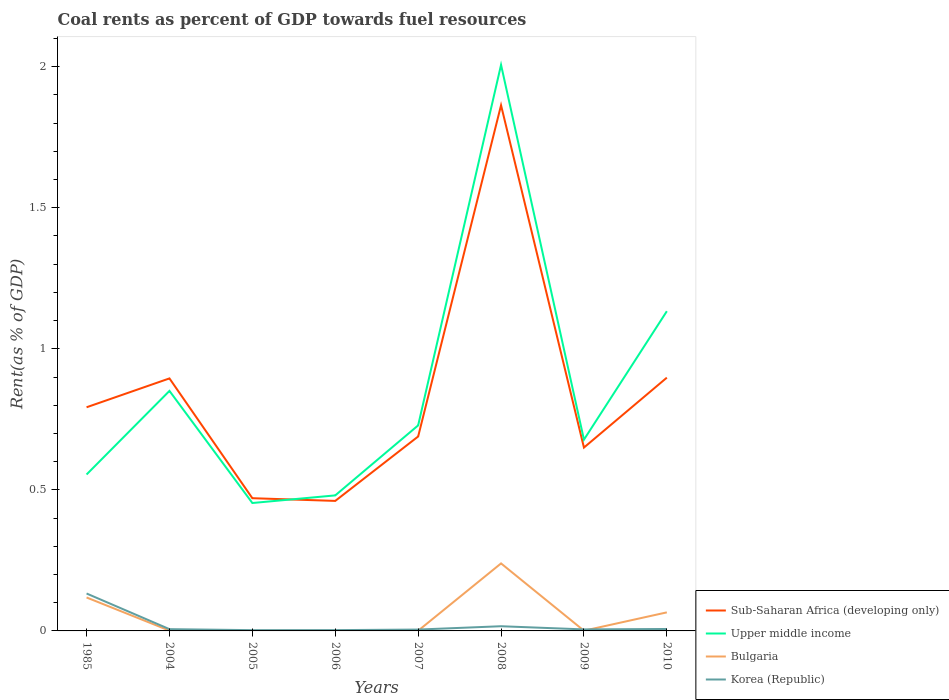Is the number of lines equal to the number of legend labels?
Offer a terse response. Yes. Across all years, what is the maximum coal rent in Bulgaria?
Make the answer very short. 6.50114927236494e-5. What is the total coal rent in Korea (Republic) in the graph?
Keep it short and to the point. -8.420606470587984e-5. What is the difference between the highest and the second highest coal rent in Korea (Republic)?
Provide a succinct answer. 0.13. Does the graph contain grids?
Provide a short and direct response. No. How are the legend labels stacked?
Offer a very short reply. Vertical. What is the title of the graph?
Your answer should be compact. Coal rents as percent of GDP towards fuel resources. What is the label or title of the X-axis?
Your response must be concise. Years. What is the label or title of the Y-axis?
Offer a terse response. Rent(as % of GDP). What is the Rent(as % of GDP) of Sub-Saharan Africa (developing only) in 1985?
Your answer should be compact. 0.79. What is the Rent(as % of GDP) in Upper middle income in 1985?
Keep it short and to the point. 0.55. What is the Rent(as % of GDP) of Bulgaria in 1985?
Make the answer very short. 0.12. What is the Rent(as % of GDP) of Korea (Republic) in 1985?
Give a very brief answer. 0.13. What is the Rent(as % of GDP) in Sub-Saharan Africa (developing only) in 2004?
Ensure brevity in your answer.  0.9. What is the Rent(as % of GDP) in Upper middle income in 2004?
Offer a terse response. 0.85. What is the Rent(as % of GDP) of Bulgaria in 2004?
Ensure brevity in your answer.  0. What is the Rent(as % of GDP) in Korea (Republic) in 2004?
Keep it short and to the point. 0.01. What is the Rent(as % of GDP) of Sub-Saharan Africa (developing only) in 2005?
Provide a succinct answer. 0.47. What is the Rent(as % of GDP) in Upper middle income in 2005?
Your answer should be compact. 0.45. What is the Rent(as % of GDP) in Bulgaria in 2005?
Offer a very short reply. 6.50114927236494e-5. What is the Rent(as % of GDP) in Korea (Republic) in 2005?
Your answer should be very brief. 0. What is the Rent(as % of GDP) of Sub-Saharan Africa (developing only) in 2006?
Keep it short and to the point. 0.46. What is the Rent(as % of GDP) in Upper middle income in 2006?
Offer a terse response. 0.48. What is the Rent(as % of GDP) in Bulgaria in 2006?
Give a very brief answer. 0. What is the Rent(as % of GDP) of Korea (Republic) in 2006?
Offer a terse response. 0. What is the Rent(as % of GDP) in Sub-Saharan Africa (developing only) in 2007?
Ensure brevity in your answer.  0.69. What is the Rent(as % of GDP) in Upper middle income in 2007?
Provide a succinct answer. 0.73. What is the Rent(as % of GDP) in Bulgaria in 2007?
Keep it short and to the point. 0. What is the Rent(as % of GDP) in Korea (Republic) in 2007?
Make the answer very short. 0. What is the Rent(as % of GDP) of Sub-Saharan Africa (developing only) in 2008?
Your answer should be compact. 1.86. What is the Rent(as % of GDP) in Upper middle income in 2008?
Your answer should be very brief. 2.01. What is the Rent(as % of GDP) in Bulgaria in 2008?
Provide a short and direct response. 0.24. What is the Rent(as % of GDP) in Korea (Republic) in 2008?
Provide a succinct answer. 0.02. What is the Rent(as % of GDP) in Sub-Saharan Africa (developing only) in 2009?
Offer a terse response. 0.65. What is the Rent(as % of GDP) in Upper middle income in 2009?
Give a very brief answer. 0.68. What is the Rent(as % of GDP) in Bulgaria in 2009?
Your answer should be very brief. 0. What is the Rent(as % of GDP) in Korea (Republic) in 2009?
Provide a succinct answer. 0.01. What is the Rent(as % of GDP) in Sub-Saharan Africa (developing only) in 2010?
Ensure brevity in your answer.  0.9. What is the Rent(as % of GDP) in Upper middle income in 2010?
Keep it short and to the point. 1.13. What is the Rent(as % of GDP) in Bulgaria in 2010?
Your answer should be very brief. 0.07. What is the Rent(as % of GDP) of Korea (Republic) in 2010?
Make the answer very short. 0.01. Across all years, what is the maximum Rent(as % of GDP) of Sub-Saharan Africa (developing only)?
Offer a very short reply. 1.86. Across all years, what is the maximum Rent(as % of GDP) of Upper middle income?
Give a very brief answer. 2.01. Across all years, what is the maximum Rent(as % of GDP) of Bulgaria?
Offer a very short reply. 0.24. Across all years, what is the maximum Rent(as % of GDP) in Korea (Republic)?
Offer a terse response. 0.13. Across all years, what is the minimum Rent(as % of GDP) of Sub-Saharan Africa (developing only)?
Provide a short and direct response. 0.46. Across all years, what is the minimum Rent(as % of GDP) in Upper middle income?
Your response must be concise. 0.45. Across all years, what is the minimum Rent(as % of GDP) in Bulgaria?
Provide a short and direct response. 6.50114927236494e-5. Across all years, what is the minimum Rent(as % of GDP) in Korea (Republic)?
Ensure brevity in your answer.  0. What is the total Rent(as % of GDP) in Sub-Saharan Africa (developing only) in the graph?
Give a very brief answer. 6.72. What is the total Rent(as % of GDP) of Upper middle income in the graph?
Provide a short and direct response. 6.88. What is the total Rent(as % of GDP) in Bulgaria in the graph?
Your answer should be very brief. 0.43. What is the total Rent(as % of GDP) of Korea (Republic) in the graph?
Offer a very short reply. 0.18. What is the difference between the Rent(as % of GDP) in Sub-Saharan Africa (developing only) in 1985 and that in 2004?
Your response must be concise. -0.1. What is the difference between the Rent(as % of GDP) of Upper middle income in 1985 and that in 2004?
Offer a very short reply. -0.3. What is the difference between the Rent(as % of GDP) in Bulgaria in 1985 and that in 2004?
Provide a short and direct response. 0.12. What is the difference between the Rent(as % of GDP) in Korea (Republic) in 1985 and that in 2004?
Keep it short and to the point. 0.13. What is the difference between the Rent(as % of GDP) of Sub-Saharan Africa (developing only) in 1985 and that in 2005?
Ensure brevity in your answer.  0.32. What is the difference between the Rent(as % of GDP) in Upper middle income in 1985 and that in 2005?
Your response must be concise. 0.1. What is the difference between the Rent(as % of GDP) of Bulgaria in 1985 and that in 2005?
Provide a succinct answer. 0.12. What is the difference between the Rent(as % of GDP) in Korea (Republic) in 1985 and that in 2005?
Provide a succinct answer. 0.13. What is the difference between the Rent(as % of GDP) in Sub-Saharan Africa (developing only) in 1985 and that in 2006?
Give a very brief answer. 0.33. What is the difference between the Rent(as % of GDP) of Upper middle income in 1985 and that in 2006?
Give a very brief answer. 0.07. What is the difference between the Rent(as % of GDP) in Bulgaria in 1985 and that in 2006?
Your response must be concise. 0.12. What is the difference between the Rent(as % of GDP) in Korea (Republic) in 1985 and that in 2006?
Give a very brief answer. 0.13. What is the difference between the Rent(as % of GDP) in Sub-Saharan Africa (developing only) in 1985 and that in 2007?
Offer a very short reply. 0.1. What is the difference between the Rent(as % of GDP) in Upper middle income in 1985 and that in 2007?
Provide a succinct answer. -0.17. What is the difference between the Rent(as % of GDP) of Bulgaria in 1985 and that in 2007?
Make the answer very short. 0.12. What is the difference between the Rent(as % of GDP) of Korea (Republic) in 1985 and that in 2007?
Offer a terse response. 0.13. What is the difference between the Rent(as % of GDP) of Sub-Saharan Africa (developing only) in 1985 and that in 2008?
Keep it short and to the point. -1.07. What is the difference between the Rent(as % of GDP) in Upper middle income in 1985 and that in 2008?
Provide a succinct answer. -1.45. What is the difference between the Rent(as % of GDP) of Bulgaria in 1985 and that in 2008?
Make the answer very short. -0.12. What is the difference between the Rent(as % of GDP) of Korea (Republic) in 1985 and that in 2008?
Ensure brevity in your answer.  0.12. What is the difference between the Rent(as % of GDP) of Sub-Saharan Africa (developing only) in 1985 and that in 2009?
Give a very brief answer. 0.14. What is the difference between the Rent(as % of GDP) in Upper middle income in 1985 and that in 2009?
Provide a succinct answer. -0.12. What is the difference between the Rent(as % of GDP) of Bulgaria in 1985 and that in 2009?
Provide a short and direct response. 0.12. What is the difference between the Rent(as % of GDP) in Korea (Republic) in 1985 and that in 2009?
Ensure brevity in your answer.  0.13. What is the difference between the Rent(as % of GDP) in Sub-Saharan Africa (developing only) in 1985 and that in 2010?
Give a very brief answer. -0.1. What is the difference between the Rent(as % of GDP) in Upper middle income in 1985 and that in 2010?
Provide a succinct answer. -0.58. What is the difference between the Rent(as % of GDP) in Bulgaria in 1985 and that in 2010?
Offer a terse response. 0.05. What is the difference between the Rent(as % of GDP) in Korea (Republic) in 1985 and that in 2010?
Give a very brief answer. 0.13. What is the difference between the Rent(as % of GDP) of Sub-Saharan Africa (developing only) in 2004 and that in 2005?
Ensure brevity in your answer.  0.42. What is the difference between the Rent(as % of GDP) of Upper middle income in 2004 and that in 2005?
Offer a terse response. 0.4. What is the difference between the Rent(as % of GDP) in Korea (Republic) in 2004 and that in 2005?
Your answer should be very brief. 0. What is the difference between the Rent(as % of GDP) of Sub-Saharan Africa (developing only) in 2004 and that in 2006?
Your answer should be very brief. 0.43. What is the difference between the Rent(as % of GDP) in Upper middle income in 2004 and that in 2006?
Offer a terse response. 0.37. What is the difference between the Rent(as % of GDP) in Bulgaria in 2004 and that in 2006?
Provide a short and direct response. 0. What is the difference between the Rent(as % of GDP) of Korea (Republic) in 2004 and that in 2006?
Offer a very short reply. 0. What is the difference between the Rent(as % of GDP) in Sub-Saharan Africa (developing only) in 2004 and that in 2007?
Your response must be concise. 0.21. What is the difference between the Rent(as % of GDP) in Upper middle income in 2004 and that in 2007?
Ensure brevity in your answer.  0.12. What is the difference between the Rent(as % of GDP) of Korea (Republic) in 2004 and that in 2007?
Your answer should be very brief. 0. What is the difference between the Rent(as % of GDP) in Sub-Saharan Africa (developing only) in 2004 and that in 2008?
Keep it short and to the point. -0.97. What is the difference between the Rent(as % of GDP) in Upper middle income in 2004 and that in 2008?
Offer a very short reply. -1.16. What is the difference between the Rent(as % of GDP) in Bulgaria in 2004 and that in 2008?
Make the answer very short. -0.24. What is the difference between the Rent(as % of GDP) in Korea (Republic) in 2004 and that in 2008?
Provide a succinct answer. -0.01. What is the difference between the Rent(as % of GDP) of Sub-Saharan Africa (developing only) in 2004 and that in 2009?
Provide a short and direct response. 0.25. What is the difference between the Rent(as % of GDP) of Upper middle income in 2004 and that in 2009?
Keep it short and to the point. 0.17. What is the difference between the Rent(as % of GDP) in Korea (Republic) in 2004 and that in 2009?
Your answer should be very brief. 0. What is the difference between the Rent(as % of GDP) of Sub-Saharan Africa (developing only) in 2004 and that in 2010?
Ensure brevity in your answer.  -0. What is the difference between the Rent(as % of GDP) of Upper middle income in 2004 and that in 2010?
Your response must be concise. -0.28. What is the difference between the Rent(as % of GDP) of Bulgaria in 2004 and that in 2010?
Ensure brevity in your answer.  -0.06. What is the difference between the Rent(as % of GDP) of Korea (Republic) in 2004 and that in 2010?
Provide a succinct answer. -0. What is the difference between the Rent(as % of GDP) in Sub-Saharan Africa (developing only) in 2005 and that in 2006?
Provide a short and direct response. 0.01. What is the difference between the Rent(as % of GDP) in Upper middle income in 2005 and that in 2006?
Offer a very short reply. -0.03. What is the difference between the Rent(as % of GDP) of Bulgaria in 2005 and that in 2006?
Your answer should be very brief. -0. What is the difference between the Rent(as % of GDP) of Korea (Republic) in 2005 and that in 2006?
Offer a very short reply. -0. What is the difference between the Rent(as % of GDP) of Sub-Saharan Africa (developing only) in 2005 and that in 2007?
Keep it short and to the point. -0.22. What is the difference between the Rent(as % of GDP) of Upper middle income in 2005 and that in 2007?
Provide a short and direct response. -0.28. What is the difference between the Rent(as % of GDP) in Bulgaria in 2005 and that in 2007?
Your response must be concise. -0. What is the difference between the Rent(as % of GDP) of Korea (Republic) in 2005 and that in 2007?
Keep it short and to the point. -0. What is the difference between the Rent(as % of GDP) of Sub-Saharan Africa (developing only) in 2005 and that in 2008?
Ensure brevity in your answer.  -1.39. What is the difference between the Rent(as % of GDP) in Upper middle income in 2005 and that in 2008?
Ensure brevity in your answer.  -1.55. What is the difference between the Rent(as % of GDP) of Bulgaria in 2005 and that in 2008?
Ensure brevity in your answer.  -0.24. What is the difference between the Rent(as % of GDP) of Korea (Republic) in 2005 and that in 2008?
Your answer should be very brief. -0.01. What is the difference between the Rent(as % of GDP) in Sub-Saharan Africa (developing only) in 2005 and that in 2009?
Your response must be concise. -0.18. What is the difference between the Rent(as % of GDP) in Upper middle income in 2005 and that in 2009?
Your answer should be very brief. -0.22. What is the difference between the Rent(as % of GDP) in Bulgaria in 2005 and that in 2009?
Provide a short and direct response. -0. What is the difference between the Rent(as % of GDP) of Korea (Republic) in 2005 and that in 2009?
Keep it short and to the point. -0. What is the difference between the Rent(as % of GDP) of Sub-Saharan Africa (developing only) in 2005 and that in 2010?
Your answer should be very brief. -0.43. What is the difference between the Rent(as % of GDP) in Upper middle income in 2005 and that in 2010?
Give a very brief answer. -0.68. What is the difference between the Rent(as % of GDP) in Bulgaria in 2005 and that in 2010?
Provide a short and direct response. -0.07. What is the difference between the Rent(as % of GDP) in Korea (Republic) in 2005 and that in 2010?
Provide a short and direct response. -0. What is the difference between the Rent(as % of GDP) of Sub-Saharan Africa (developing only) in 2006 and that in 2007?
Provide a succinct answer. -0.23. What is the difference between the Rent(as % of GDP) of Upper middle income in 2006 and that in 2007?
Offer a terse response. -0.25. What is the difference between the Rent(as % of GDP) in Bulgaria in 2006 and that in 2007?
Ensure brevity in your answer.  -0. What is the difference between the Rent(as % of GDP) in Korea (Republic) in 2006 and that in 2007?
Make the answer very short. -0. What is the difference between the Rent(as % of GDP) of Sub-Saharan Africa (developing only) in 2006 and that in 2008?
Provide a short and direct response. -1.4. What is the difference between the Rent(as % of GDP) in Upper middle income in 2006 and that in 2008?
Your answer should be compact. -1.53. What is the difference between the Rent(as % of GDP) of Bulgaria in 2006 and that in 2008?
Your answer should be very brief. -0.24. What is the difference between the Rent(as % of GDP) in Korea (Republic) in 2006 and that in 2008?
Your answer should be very brief. -0.01. What is the difference between the Rent(as % of GDP) of Sub-Saharan Africa (developing only) in 2006 and that in 2009?
Your response must be concise. -0.19. What is the difference between the Rent(as % of GDP) of Upper middle income in 2006 and that in 2009?
Your answer should be compact. -0.2. What is the difference between the Rent(as % of GDP) in Bulgaria in 2006 and that in 2009?
Offer a terse response. -0. What is the difference between the Rent(as % of GDP) of Korea (Republic) in 2006 and that in 2009?
Your response must be concise. -0. What is the difference between the Rent(as % of GDP) in Sub-Saharan Africa (developing only) in 2006 and that in 2010?
Offer a terse response. -0.44. What is the difference between the Rent(as % of GDP) of Upper middle income in 2006 and that in 2010?
Your response must be concise. -0.65. What is the difference between the Rent(as % of GDP) in Bulgaria in 2006 and that in 2010?
Your response must be concise. -0.07. What is the difference between the Rent(as % of GDP) in Korea (Republic) in 2006 and that in 2010?
Offer a very short reply. -0. What is the difference between the Rent(as % of GDP) in Sub-Saharan Africa (developing only) in 2007 and that in 2008?
Make the answer very short. -1.17. What is the difference between the Rent(as % of GDP) of Upper middle income in 2007 and that in 2008?
Ensure brevity in your answer.  -1.28. What is the difference between the Rent(as % of GDP) of Bulgaria in 2007 and that in 2008?
Provide a succinct answer. -0.24. What is the difference between the Rent(as % of GDP) in Korea (Republic) in 2007 and that in 2008?
Provide a short and direct response. -0.01. What is the difference between the Rent(as % of GDP) in Sub-Saharan Africa (developing only) in 2007 and that in 2009?
Ensure brevity in your answer.  0.04. What is the difference between the Rent(as % of GDP) of Upper middle income in 2007 and that in 2009?
Ensure brevity in your answer.  0.05. What is the difference between the Rent(as % of GDP) in Bulgaria in 2007 and that in 2009?
Offer a terse response. -0. What is the difference between the Rent(as % of GDP) in Korea (Republic) in 2007 and that in 2009?
Offer a very short reply. -0. What is the difference between the Rent(as % of GDP) of Sub-Saharan Africa (developing only) in 2007 and that in 2010?
Your answer should be compact. -0.21. What is the difference between the Rent(as % of GDP) in Upper middle income in 2007 and that in 2010?
Give a very brief answer. -0.4. What is the difference between the Rent(as % of GDP) in Bulgaria in 2007 and that in 2010?
Ensure brevity in your answer.  -0.07. What is the difference between the Rent(as % of GDP) of Korea (Republic) in 2007 and that in 2010?
Make the answer very short. -0. What is the difference between the Rent(as % of GDP) in Sub-Saharan Africa (developing only) in 2008 and that in 2009?
Provide a short and direct response. 1.21. What is the difference between the Rent(as % of GDP) in Upper middle income in 2008 and that in 2009?
Make the answer very short. 1.33. What is the difference between the Rent(as % of GDP) of Bulgaria in 2008 and that in 2009?
Your response must be concise. 0.24. What is the difference between the Rent(as % of GDP) of Korea (Republic) in 2008 and that in 2009?
Give a very brief answer. 0.01. What is the difference between the Rent(as % of GDP) in Sub-Saharan Africa (developing only) in 2008 and that in 2010?
Provide a succinct answer. 0.97. What is the difference between the Rent(as % of GDP) of Upper middle income in 2008 and that in 2010?
Keep it short and to the point. 0.87. What is the difference between the Rent(as % of GDP) in Bulgaria in 2008 and that in 2010?
Keep it short and to the point. 0.17. What is the difference between the Rent(as % of GDP) of Korea (Republic) in 2008 and that in 2010?
Your answer should be very brief. 0.01. What is the difference between the Rent(as % of GDP) in Sub-Saharan Africa (developing only) in 2009 and that in 2010?
Keep it short and to the point. -0.25. What is the difference between the Rent(as % of GDP) of Upper middle income in 2009 and that in 2010?
Offer a very short reply. -0.46. What is the difference between the Rent(as % of GDP) of Bulgaria in 2009 and that in 2010?
Your response must be concise. -0.07. What is the difference between the Rent(as % of GDP) in Korea (Republic) in 2009 and that in 2010?
Give a very brief answer. -0. What is the difference between the Rent(as % of GDP) in Sub-Saharan Africa (developing only) in 1985 and the Rent(as % of GDP) in Upper middle income in 2004?
Offer a terse response. -0.06. What is the difference between the Rent(as % of GDP) in Sub-Saharan Africa (developing only) in 1985 and the Rent(as % of GDP) in Bulgaria in 2004?
Your answer should be compact. 0.79. What is the difference between the Rent(as % of GDP) of Sub-Saharan Africa (developing only) in 1985 and the Rent(as % of GDP) of Korea (Republic) in 2004?
Keep it short and to the point. 0.79. What is the difference between the Rent(as % of GDP) in Upper middle income in 1985 and the Rent(as % of GDP) in Bulgaria in 2004?
Make the answer very short. 0.55. What is the difference between the Rent(as % of GDP) of Upper middle income in 1985 and the Rent(as % of GDP) of Korea (Republic) in 2004?
Offer a terse response. 0.55. What is the difference between the Rent(as % of GDP) of Bulgaria in 1985 and the Rent(as % of GDP) of Korea (Republic) in 2004?
Offer a terse response. 0.11. What is the difference between the Rent(as % of GDP) in Sub-Saharan Africa (developing only) in 1985 and the Rent(as % of GDP) in Upper middle income in 2005?
Keep it short and to the point. 0.34. What is the difference between the Rent(as % of GDP) of Sub-Saharan Africa (developing only) in 1985 and the Rent(as % of GDP) of Bulgaria in 2005?
Your answer should be very brief. 0.79. What is the difference between the Rent(as % of GDP) of Sub-Saharan Africa (developing only) in 1985 and the Rent(as % of GDP) of Korea (Republic) in 2005?
Your response must be concise. 0.79. What is the difference between the Rent(as % of GDP) of Upper middle income in 1985 and the Rent(as % of GDP) of Bulgaria in 2005?
Give a very brief answer. 0.55. What is the difference between the Rent(as % of GDP) in Upper middle income in 1985 and the Rent(as % of GDP) in Korea (Republic) in 2005?
Offer a very short reply. 0.55. What is the difference between the Rent(as % of GDP) in Bulgaria in 1985 and the Rent(as % of GDP) in Korea (Republic) in 2005?
Keep it short and to the point. 0.12. What is the difference between the Rent(as % of GDP) in Sub-Saharan Africa (developing only) in 1985 and the Rent(as % of GDP) in Upper middle income in 2006?
Offer a very short reply. 0.31. What is the difference between the Rent(as % of GDP) in Sub-Saharan Africa (developing only) in 1985 and the Rent(as % of GDP) in Bulgaria in 2006?
Offer a very short reply. 0.79. What is the difference between the Rent(as % of GDP) of Sub-Saharan Africa (developing only) in 1985 and the Rent(as % of GDP) of Korea (Republic) in 2006?
Provide a short and direct response. 0.79. What is the difference between the Rent(as % of GDP) in Upper middle income in 1985 and the Rent(as % of GDP) in Bulgaria in 2006?
Offer a very short reply. 0.55. What is the difference between the Rent(as % of GDP) in Upper middle income in 1985 and the Rent(as % of GDP) in Korea (Republic) in 2006?
Make the answer very short. 0.55. What is the difference between the Rent(as % of GDP) in Bulgaria in 1985 and the Rent(as % of GDP) in Korea (Republic) in 2006?
Offer a very short reply. 0.12. What is the difference between the Rent(as % of GDP) in Sub-Saharan Africa (developing only) in 1985 and the Rent(as % of GDP) in Upper middle income in 2007?
Offer a terse response. 0.06. What is the difference between the Rent(as % of GDP) of Sub-Saharan Africa (developing only) in 1985 and the Rent(as % of GDP) of Bulgaria in 2007?
Offer a terse response. 0.79. What is the difference between the Rent(as % of GDP) in Sub-Saharan Africa (developing only) in 1985 and the Rent(as % of GDP) in Korea (Republic) in 2007?
Your answer should be compact. 0.79. What is the difference between the Rent(as % of GDP) of Upper middle income in 1985 and the Rent(as % of GDP) of Bulgaria in 2007?
Give a very brief answer. 0.55. What is the difference between the Rent(as % of GDP) of Upper middle income in 1985 and the Rent(as % of GDP) of Korea (Republic) in 2007?
Your answer should be compact. 0.55. What is the difference between the Rent(as % of GDP) of Bulgaria in 1985 and the Rent(as % of GDP) of Korea (Republic) in 2007?
Provide a short and direct response. 0.11. What is the difference between the Rent(as % of GDP) in Sub-Saharan Africa (developing only) in 1985 and the Rent(as % of GDP) in Upper middle income in 2008?
Keep it short and to the point. -1.21. What is the difference between the Rent(as % of GDP) in Sub-Saharan Africa (developing only) in 1985 and the Rent(as % of GDP) in Bulgaria in 2008?
Ensure brevity in your answer.  0.55. What is the difference between the Rent(as % of GDP) of Sub-Saharan Africa (developing only) in 1985 and the Rent(as % of GDP) of Korea (Republic) in 2008?
Keep it short and to the point. 0.78. What is the difference between the Rent(as % of GDP) of Upper middle income in 1985 and the Rent(as % of GDP) of Bulgaria in 2008?
Your answer should be compact. 0.32. What is the difference between the Rent(as % of GDP) in Upper middle income in 1985 and the Rent(as % of GDP) in Korea (Republic) in 2008?
Ensure brevity in your answer.  0.54. What is the difference between the Rent(as % of GDP) of Bulgaria in 1985 and the Rent(as % of GDP) of Korea (Republic) in 2008?
Your response must be concise. 0.1. What is the difference between the Rent(as % of GDP) of Sub-Saharan Africa (developing only) in 1985 and the Rent(as % of GDP) of Upper middle income in 2009?
Your answer should be compact. 0.11. What is the difference between the Rent(as % of GDP) of Sub-Saharan Africa (developing only) in 1985 and the Rent(as % of GDP) of Bulgaria in 2009?
Provide a succinct answer. 0.79. What is the difference between the Rent(as % of GDP) of Sub-Saharan Africa (developing only) in 1985 and the Rent(as % of GDP) of Korea (Republic) in 2009?
Provide a succinct answer. 0.79. What is the difference between the Rent(as % of GDP) of Upper middle income in 1985 and the Rent(as % of GDP) of Bulgaria in 2009?
Provide a succinct answer. 0.55. What is the difference between the Rent(as % of GDP) of Upper middle income in 1985 and the Rent(as % of GDP) of Korea (Republic) in 2009?
Offer a terse response. 0.55. What is the difference between the Rent(as % of GDP) in Bulgaria in 1985 and the Rent(as % of GDP) in Korea (Republic) in 2009?
Offer a very short reply. 0.11. What is the difference between the Rent(as % of GDP) in Sub-Saharan Africa (developing only) in 1985 and the Rent(as % of GDP) in Upper middle income in 2010?
Your response must be concise. -0.34. What is the difference between the Rent(as % of GDP) in Sub-Saharan Africa (developing only) in 1985 and the Rent(as % of GDP) in Bulgaria in 2010?
Keep it short and to the point. 0.73. What is the difference between the Rent(as % of GDP) in Sub-Saharan Africa (developing only) in 1985 and the Rent(as % of GDP) in Korea (Republic) in 2010?
Your answer should be very brief. 0.79. What is the difference between the Rent(as % of GDP) of Upper middle income in 1985 and the Rent(as % of GDP) of Bulgaria in 2010?
Offer a very short reply. 0.49. What is the difference between the Rent(as % of GDP) in Upper middle income in 1985 and the Rent(as % of GDP) in Korea (Republic) in 2010?
Your response must be concise. 0.55. What is the difference between the Rent(as % of GDP) in Bulgaria in 1985 and the Rent(as % of GDP) in Korea (Republic) in 2010?
Your response must be concise. 0.11. What is the difference between the Rent(as % of GDP) of Sub-Saharan Africa (developing only) in 2004 and the Rent(as % of GDP) of Upper middle income in 2005?
Your response must be concise. 0.44. What is the difference between the Rent(as % of GDP) in Sub-Saharan Africa (developing only) in 2004 and the Rent(as % of GDP) in Bulgaria in 2005?
Your answer should be very brief. 0.89. What is the difference between the Rent(as % of GDP) in Sub-Saharan Africa (developing only) in 2004 and the Rent(as % of GDP) in Korea (Republic) in 2005?
Offer a very short reply. 0.89. What is the difference between the Rent(as % of GDP) of Upper middle income in 2004 and the Rent(as % of GDP) of Bulgaria in 2005?
Your answer should be very brief. 0.85. What is the difference between the Rent(as % of GDP) of Upper middle income in 2004 and the Rent(as % of GDP) of Korea (Republic) in 2005?
Ensure brevity in your answer.  0.85. What is the difference between the Rent(as % of GDP) in Bulgaria in 2004 and the Rent(as % of GDP) in Korea (Republic) in 2005?
Your answer should be compact. -0. What is the difference between the Rent(as % of GDP) in Sub-Saharan Africa (developing only) in 2004 and the Rent(as % of GDP) in Upper middle income in 2006?
Provide a succinct answer. 0.41. What is the difference between the Rent(as % of GDP) in Sub-Saharan Africa (developing only) in 2004 and the Rent(as % of GDP) in Bulgaria in 2006?
Make the answer very short. 0.89. What is the difference between the Rent(as % of GDP) in Sub-Saharan Africa (developing only) in 2004 and the Rent(as % of GDP) in Korea (Republic) in 2006?
Your answer should be very brief. 0.89. What is the difference between the Rent(as % of GDP) of Upper middle income in 2004 and the Rent(as % of GDP) of Bulgaria in 2006?
Keep it short and to the point. 0.85. What is the difference between the Rent(as % of GDP) in Upper middle income in 2004 and the Rent(as % of GDP) in Korea (Republic) in 2006?
Provide a succinct answer. 0.85. What is the difference between the Rent(as % of GDP) in Bulgaria in 2004 and the Rent(as % of GDP) in Korea (Republic) in 2006?
Provide a short and direct response. -0. What is the difference between the Rent(as % of GDP) of Sub-Saharan Africa (developing only) in 2004 and the Rent(as % of GDP) of Upper middle income in 2007?
Provide a succinct answer. 0.17. What is the difference between the Rent(as % of GDP) of Sub-Saharan Africa (developing only) in 2004 and the Rent(as % of GDP) of Bulgaria in 2007?
Offer a terse response. 0.89. What is the difference between the Rent(as % of GDP) of Sub-Saharan Africa (developing only) in 2004 and the Rent(as % of GDP) of Korea (Republic) in 2007?
Your response must be concise. 0.89. What is the difference between the Rent(as % of GDP) in Upper middle income in 2004 and the Rent(as % of GDP) in Bulgaria in 2007?
Your answer should be very brief. 0.85. What is the difference between the Rent(as % of GDP) in Upper middle income in 2004 and the Rent(as % of GDP) in Korea (Republic) in 2007?
Make the answer very short. 0.85. What is the difference between the Rent(as % of GDP) of Bulgaria in 2004 and the Rent(as % of GDP) of Korea (Republic) in 2007?
Make the answer very short. -0. What is the difference between the Rent(as % of GDP) of Sub-Saharan Africa (developing only) in 2004 and the Rent(as % of GDP) of Upper middle income in 2008?
Give a very brief answer. -1.11. What is the difference between the Rent(as % of GDP) in Sub-Saharan Africa (developing only) in 2004 and the Rent(as % of GDP) in Bulgaria in 2008?
Keep it short and to the point. 0.66. What is the difference between the Rent(as % of GDP) in Sub-Saharan Africa (developing only) in 2004 and the Rent(as % of GDP) in Korea (Republic) in 2008?
Make the answer very short. 0.88. What is the difference between the Rent(as % of GDP) in Upper middle income in 2004 and the Rent(as % of GDP) in Bulgaria in 2008?
Your response must be concise. 0.61. What is the difference between the Rent(as % of GDP) of Upper middle income in 2004 and the Rent(as % of GDP) of Korea (Republic) in 2008?
Offer a terse response. 0.83. What is the difference between the Rent(as % of GDP) in Bulgaria in 2004 and the Rent(as % of GDP) in Korea (Republic) in 2008?
Keep it short and to the point. -0.02. What is the difference between the Rent(as % of GDP) in Sub-Saharan Africa (developing only) in 2004 and the Rent(as % of GDP) in Upper middle income in 2009?
Offer a terse response. 0.22. What is the difference between the Rent(as % of GDP) of Sub-Saharan Africa (developing only) in 2004 and the Rent(as % of GDP) of Bulgaria in 2009?
Give a very brief answer. 0.89. What is the difference between the Rent(as % of GDP) in Sub-Saharan Africa (developing only) in 2004 and the Rent(as % of GDP) in Korea (Republic) in 2009?
Your answer should be compact. 0.89. What is the difference between the Rent(as % of GDP) in Upper middle income in 2004 and the Rent(as % of GDP) in Bulgaria in 2009?
Your answer should be very brief. 0.85. What is the difference between the Rent(as % of GDP) of Upper middle income in 2004 and the Rent(as % of GDP) of Korea (Republic) in 2009?
Give a very brief answer. 0.85. What is the difference between the Rent(as % of GDP) in Bulgaria in 2004 and the Rent(as % of GDP) in Korea (Republic) in 2009?
Provide a succinct answer. -0. What is the difference between the Rent(as % of GDP) in Sub-Saharan Africa (developing only) in 2004 and the Rent(as % of GDP) in Upper middle income in 2010?
Offer a very short reply. -0.24. What is the difference between the Rent(as % of GDP) of Sub-Saharan Africa (developing only) in 2004 and the Rent(as % of GDP) of Bulgaria in 2010?
Give a very brief answer. 0.83. What is the difference between the Rent(as % of GDP) of Sub-Saharan Africa (developing only) in 2004 and the Rent(as % of GDP) of Korea (Republic) in 2010?
Offer a terse response. 0.89. What is the difference between the Rent(as % of GDP) of Upper middle income in 2004 and the Rent(as % of GDP) of Bulgaria in 2010?
Ensure brevity in your answer.  0.78. What is the difference between the Rent(as % of GDP) of Upper middle income in 2004 and the Rent(as % of GDP) of Korea (Republic) in 2010?
Your response must be concise. 0.84. What is the difference between the Rent(as % of GDP) of Bulgaria in 2004 and the Rent(as % of GDP) of Korea (Republic) in 2010?
Your answer should be compact. -0.01. What is the difference between the Rent(as % of GDP) in Sub-Saharan Africa (developing only) in 2005 and the Rent(as % of GDP) in Upper middle income in 2006?
Ensure brevity in your answer.  -0.01. What is the difference between the Rent(as % of GDP) in Sub-Saharan Africa (developing only) in 2005 and the Rent(as % of GDP) in Bulgaria in 2006?
Your answer should be very brief. 0.47. What is the difference between the Rent(as % of GDP) of Sub-Saharan Africa (developing only) in 2005 and the Rent(as % of GDP) of Korea (Republic) in 2006?
Your answer should be very brief. 0.47. What is the difference between the Rent(as % of GDP) in Upper middle income in 2005 and the Rent(as % of GDP) in Bulgaria in 2006?
Offer a very short reply. 0.45. What is the difference between the Rent(as % of GDP) in Upper middle income in 2005 and the Rent(as % of GDP) in Korea (Republic) in 2006?
Make the answer very short. 0.45. What is the difference between the Rent(as % of GDP) in Bulgaria in 2005 and the Rent(as % of GDP) in Korea (Republic) in 2006?
Give a very brief answer. -0. What is the difference between the Rent(as % of GDP) of Sub-Saharan Africa (developing only) in 2005 and the Rent(as % of GDP) of Upper middle income in 2007?
Your answer should be compact. -0.26. What is the difference between the Rent(as % of GDP) of Sub-Saharan Africa (developing only) in 2005 and the Rent(as % of GDP) of Bulgaria in 2007?
Your answer should be compact. 0.47. What is the difference between the Rent(as % of GDP) in Sub-Saharan Africa (developing only) in 2005 and the Rent(as % of GDP) in Korea (Republic) in 2007?
Give a very brief answer. 0.47. What is the difference between the Rent(as % of GDP) of Upper middle income in 2005 and the Rent(as % of GDP) of Bulgaria in 2007?
Your answer should be very brief. 0.45. What is the difference between the Rent(as % of GDP) of Upper middle income in 2005 and the Rent(as % of GDP) of Korea (Republic) in 2007?
Offer a very short reply. 0.45. What is the difference between the Rent(as % of GDP) in Bulgaria in 2005 and the Rent(as % of GDP) in Korea (Republic) in 2007?
Your response must be concise. -0. What is the difference between the Rent(as % of GDP) in Sub-Saharan Africa (developing only) in 2005 and the Rent(as % of GDP) in Upper middle income in 2008?
Make the answer very short. -1.54. What is the difference between the Rent(as % of GDP) in Sub-Saharan Africa (developing only) in 2005 and the Rent(as % of GDP) in Bulgaria in 2008?
Provide a short and direct response. 0.23. What is the difference between the Rent(as % of GDP) in Sub-Saharan Africa (developing only) in 2005 and the Rent(as % of GDP) in Korea (Republic) in 2008?
Keep it short and to the point. 0.45. What is the difference between the Rent(as % of GDP) in Upper middle income in 2005 and the Rent(as % of GDP) in Bulgaria in 2008?
Provide a short and direct response. 0.21. What is the difference between the Rent(as % of GDP) in Upper middle income in 2005 and the Rent(as % of GDP) in Korea (Republic) in 2008?
Provide a succinct answer. 0.44. What is the difference between the Rent(as % of GDP) of Bulgaria in 2005 and the Rent(as % of GDP) of Korea (Republic) in 2008?
Keep it short and to the point. -0.02. What is the difference between the Rent(as % of GDP) in Sub-Saharan Africa (developing only) in 2005 and the Rent(as % of GDP) in Upper middle income in 2009?
Ensure brevity in your answer.  -0.21. What is the difference between the Rent(as % of GDP) of Sub-Saharan Africa (developing only) in 2005 and the Rent(as % of GDP) of Bulgaria in 2009?
Keep it short and to the point. 0.47. What is the difference between the Rent(as % of GDP) of Sub-Saharan Africa (developing only) in 2005 and the Rent(as % of GDP) of Korea (Republic) in 2009?
Ensure brevity in your answer.  0.47. What is the difference between the Rent(as % of GDP) in Upper middle income in 2005 and the Rent(as % of GDP) in Bulgaria in 2009?
Make the answer very short. 0.45. What is the difference between the Rent(as % of GDP) of Upper middle income in 2005 and the Rent(as % of GDP) of Korea (Republic) in 2009?
Ensure brevity in your answer.  0.45. What is the difference between the Rent(as % of GDP) of Bulgaria in 2005 and the Rent(as % of GDP) of Korea (Republic) in 2009?
Give a very brief answer. -0.01. What is the difference between the Rent(as % of GDP) in Sub-Saharan Africa (developing only) in 2005 and the Rent(as % of GDP) in Upper middle income in 2010?
Give a very brief answer. -0.66. What is the difference between the Rent(as % of GDP) of Sub-Saharan Africa (developing only) in 2005 and the Rent(as % of GDP) of Bulgaria in 2010?
Your answer should be very brief. 0.4. What is the difference between the Rent(as % of GDP) in Sub-Saharan Africa (developing only) in 2005 and the Rent(as % of GDP) in Korea (Republic) in 2010?
Make the answer very short. 0.46. What is the difference between the Rent(as % of GDP) in Upper middle income in 2005 and the Rent(as % of GDP) in Bulgaria in 2010?
Your answer should be compact. 0.39. What is the difference between the Rent(as % of GDP) of Upper middle income in 2005 and the Rent(as % of GDP) of Korea (Republic) in 2010?
Provide a succinct answer. 0.45. What is the difference between the Rent(as % of GDP) of Bulgaria in 2005 and the Rent(as % of GDP) of Korea (Republic) in 2010?
Make the answer very short. -0.01. What is the difference between the Rent(as % of GDP) of Sub-Saharan Africa (developing only) in 2006 and the Rent(as % of GDP) of Upper middle income in 2007?
Give a very brief answer. -0.27. What is the difference between the Rent(as % of GDP) of Sub-Saharan Africa (developing only) in 2006 and the Rent(as % of GDP) of Bulgaria in 2007?
Offer a terse response. 0.46. What is the difference between the Rent(as % of GDP) of Sub-Saharan Africa (developing only) in 2006 and the Rent(as % of GDP) of Korea (Republic) in 2007?
Your answer should be compact. 0.46. What is the difference between the Rent(as % of GDP) of Upper middle income in 2006 and the Rent(as % of GDP) of Bulgaria in 2007?
Ensure brevity in your answer.  0.48. What is the difference between the Rent(as % of GDP) in Upper middle income in 2006 and the Rent(as % of GDP) in Korea (Republic) in 2007?
Keep it short and to the point. 0.48. What is the difference between the Rent(as % of GDP) in Bulgaria in 2006 and the Rent(as % of GDP) in Korea (Republic) in 2007?
Make the answer very short. -0. What is the difference between the Rent(as % of GDP) in Sub-Saharan Africa (developing only) in 2006 and the Rent(as % of GDP) in Upper middle income in 2008?
Offer a very short reply. -1.55. What is the difference between the Rent(as % of GDP) of Sub-Saharan Africa (developing only) in 2006 and the Rent(as % of GDP) of Bulgaria in 2008?
Your answer should be very brief. 0.22. What is the difference between the Rent(as % of GDP) of Sub-Saharan Africa (developing only) in 2006 and the Rent(as % of GDP) of Korea (Republic) in 2008?
Provide a short and direct response. 0.44. What is the difference between the Rent(as % of GDP) in Upper middle income in 2006 and the Rent(as % of GDP) in Bulgaria in 2008?
Provide a succinct answer. 0.24. What is the difference between the Rent(as % of GDP) in Upper middle income in 2006 and the Rent(as % of GDP) in Korea (Republic) in 2008?
Your response must be concise. 0.46. What is the difference between the Rent(as % of GDP) in Bulgaria in 2006 and the Rent(as % of GDP) in Korea (Republic) in 2008?
Ensure brevity in your answer.  -0.02. What is the difference between the Rent(as % of GDP) of Sub-Saharan Africa (developing only) in 2006 and the Rent(as % of GDP) of Upper middle income in 2009?
Ensure brevity in your answer.  -0.22. What is the difference between the Rent(as % of GDP) in Sub-Saharan Africa (developing only) in 2006 and the Rent(as % of GDP) in Bulgaria in 2009?
Your answer should be very brief. 0.46. What is the difference between the Rent(as % of GDP) in Sub-Saharan Africa (developing only) in 2006 and the Rent(as % of GDP) in Korea (Republic) in 2009?
Your answer should be very brief. 0.46. What is the difference between the Rent(as % of GDP) in Upper middle income in 2006 and the Rent(as % of GDP) in Bulgaria in 2009?
Ensure brevity in your answer.  0.48. What is the difference between the Rent(as % of GDP) of Upper middle income in 2006 and the Rent(as % of GDP) of Korea (Republic) in 2009?
Offer a very short reply. 0.47. What is the difference between the Rent(as % of GDP) in Bulgaria in 2006 and the Rent(as % of GDP) in Korea (Republic) in 2009?
Your answer should be very brief. -0.01. What is the difference between the Rent(as % of GDP) in Sub-Saharan Africa (developing only) in 2006 and the Rent(as % of GDP) in Upper middle income in 2010?
Provide a succinct answer. -0.67. What is the difference between the Rent(as % of GDP) of Sub-Saharan Africa (developing only) in 2006 and the Rent(as % of GDP) of Bulgaria in 2010?
Your response must be concise. 0.4. What is the difference between the Rent(as % of GDP) of Sub-Saharan Africa (developing only) in 2006 and the Rent(as % of GDP) of Korea (Republic) in 2010?
Give a very brief answer. 0.45. What is the difference between the Rent(as % of GDP) in Upper middle income in 2006 and the Rent(as % of GDP) in Bulgaria in 2010?
Provide a short and direct response. 0.41. What is the difference between the Rent(as % of GDP) of Upper middle income in 2006 and the Rent(as % of GDP) of Korea (Republic) in 2010?
Your response must be concise. 0.47. What is the difference between the Rent(as % of GDP) in Bulgaria in 2006 and the Rent(as % of GDP) in Korea (Republic) in 2010?
Your response must be concise. -0.01. What is the difference between the Rent(as % of GDP) in Sub-Saharan Africa (developing only) in 2007 and the Rent(as % of GDP) in Upper middle income in 2008?
Keep it short and to the point. -1.32. What is the difference between the Rent(as % of GDP) in Sub-Saharan Africa (developing only) in 2007 and the Rent(as % of GDP) in Bulgaria in 2008?
Provide a succinct answer. 0.45. What is the difference between the Rent(as % of GDP) in Sub-Saharan Africa (developing only) in 2007 and the Rent(as % of GDP) in Korea (Republic) in 2008?
Make the answer very short. 0.67. What is the difference between the Rent(as % of GDP) in Upper middle income in 2007 and the Rent(as % of GDP) in Bulgaria in 2008?
Ensure brevity in your answer.  0.49. What is the difference between the Rent(as % of GDP) in Upper middle income in 2007 and the Rent(as % of GDP) in Korea (Republic) in 2008?
Ensure brevity in your answer.  0.71. What is the difference between the Rent(as % of GDP) of Bulgaria in 2007 and the Rent(as % of GDP) of Korea (Republic) in 2008?
Make the answer very short. -0.02. What is the difference between the Rent(as % of GDP) of Sub-Saharan Africa (developing only) in 2007 and the Rent(as % of GDP) of Upper middle income in 2009?
Make the answer very short. 0.01. What is the difference between the Rent(as % of GDP) in Sub-Saharan Africa (developing only) in 2007 and the Rent(as % of GDP) in Bulgaria in 2009?
Your response must be concise. 0.69. What is the difference between the Rent(as % of GDP) of Sub-Saharan Africa (developing only) in 2007 and the Rent(as % of GDP) of Korea (Republic) in 2009?
Your answer should be compact. 0.68. What is the difference between the Rent(as % of GDP) of Upper middle income in 2007 and the Rent(as % of GDP) of Bulgaria in 2009?
Keep it short and to the point. 0.73. What is the difference between the Rent(as % of GDP) in Upper middle income in 2007 and the Rent(as % of GDP) in Korea (Republic) in 2009?
Keep it short and to the point. 0.72. What is the difference between the Rent(as % of GDP) in Bulgaria in 2007 and the Rent(as % of GDP) in Korea (Republic) in 2009?
Ensure brevity in your answer.  -0. What is the difference between the Rent(as % of GDP) of Sub-Saharan Africa (developing only) in 2007 and the Rent(as % of GDP) of Upper middle income in 2010?
Offer a terse response. -0.44. What is the difference between the Rent(as % of GDP) of Sub-Saharan Africa (developing only) in 2007 and the Rent(as % of GDP) of Bulgaria in 2010?
Give a very brief answer. 0.62. What is the difference between the Rent(as % of GDP) in Sub-Saharan Africa (developing only) in 2007 and the Rent(as % of GDP) in Korea (Republic) in 2010?
Your response must be concise. 0.68. What is the difference between the Rent(as % of GDP) in Upper middle income in 2007 and the Rent(as % of GDP) in Bulgaria in 2010?
Ensure brevity in your answer.  0.66. What is the difference between the Rent(as % of GDP) of Upper middle income in 2007 and the Rent(as % of GDP) of Korea (Republic) in 2010?
Your answer should be very brief. 0.72. What is the difference between the Rent(as % of GDP) in Bulgaria in 2007 and the Rent(as % of GDP) in Korea (Republic) in 2010?
Your answer should be very brief. -0.01. What is the difference between the Rent(as % of GDP) of Sub-Saharan Africa (developing only) in 2008 and the Rent(as % of GDP) of Upper middle income in 2009?
Offer a terse response. 1.19. What is the difference between the Rent(as % of GDP) in Sub-Saharan Africa (developing only) in 2008 and the Rent(as % of GDP) in Bulgaria in 2009?
Provide a short and direct response. 1.86. What is the difference between the Rent(as % of GDP) of Sub-Saharan Africa (developing only) in 2008 and the Rent(as % of GDP) of Korea (Republic) in 2009?
Keep it short and to the point. 1.86. What is the difference between the Rent(as % of GDP) in Upper middle income in 2008 and the Rent(as % of GDP) in Bulgaria in 2009?
Provide a succinct answer. 2.01. What is the difference between the Rent(as % of GDP) of Upper middle income in 2008 and the Rent(as % of GDP) of Korea (Republic) in 2009?
Provide a short and direct response. 2. What is the difference between the Rent(as % of GDP) of Bulgaria in 2008 and the Rent(as % of GDP) of Korea (Republic) in 2009?
Give a very brief answer. 0.23. What is the difference between the Rent(as % of GDP) of Sub-Saharan Africa (developing only) in 2008 and the Rent(as % of GDP) of Upper middle income in 2010?
Offer a terse response. 0.73. What is the difference between the Rent(as % of GDP) in Sub-Saharan Africa (developing only) in 2008 and the Rent(as % of GDP) in Bulgaria in 2010?
Provide a short and direct response. 1.8. What is the difference between the Rent(as % of GDP) in Sub-Saharan Africa (developing only) in 2008 and the Rent(as % of GDP) in Korea (Republic) in 2010?
Your response must be concise. 1.86. What is the difference between the Rent(as % of GDP) of Upper middle income in 2008 and the Rent(as % of GDP) of Bulgaria in 2010?
Make the answer very short. 1.94. What is the difference between the Rent(as % of GDP) of Upper middle income in 2008 and the Rent(as % of GDP) of Korea (Republic) in 2010?
Offer a very short reply. 2. What is the difference between the Rent(as % of GDP) of Bulgaria in 2008 and the Rent(as % of GDP) of Korea (Republic) in 2010?
Offer a terse response. 0.23. What is the difference between the Rent(as % of GDP) of Sub-Saharan Africa (developing only) in 2009 and the Rent(as % of GDP) of Upper middle income in 2010?
Keep it short and to the point. -0.48. What is the difference between the Rent(as % of GDP) of Sub-Saharan Africa (developing only) in 2009 and the Rent(as % of GDP) of Bulgaria in 2010?
Offer a very short reply. 0.58. What is the difference between the Rent(as % of GDP) in Sub-Saharan Africa (developing only) in 2009 and the Rent(as % of GDP) in Korea (Republic) in 2010?
Offer a very short reply. 0.64. What is the difference between the Rent(as % of GDP) of Upper middle income in 2009 and the Rent(as % of GDP) of Bulgaria in 2010?
Give a very brief answer. 0.61. What is the difference between the Rent(as % of GDP) in Upper middle income in 2009 and the Rent(as % of GDP) in Korea (Republic) in 2010?
Offer a very short reply. 0.67. What is the difference between the Rent(as % of GDP) of Bulgaria in 2009 and the Rent(as % of GDP) of Korea (Republic) in 2010?
Offer a terse response. -0.01. What is the average Rent(as % of GDP) in Sub-Saharan Africa (developing only) per year?
Provide a short and direct response. 0.84. What is the average Rent(as % of GDP) of Upper middle income per year?
Offer a very short reply. 0.86. What is the average Rent(as % of GDP) in Bulgaria per year?
Ensure brevity in your answer.  0.05. What is the average Rent(as % of GDP) of Korea (Republic) per year?
Ensure brevity in your answer.  0.02. In the year 1985, what is the difference between the Rent(as % of GDP) of Sub-Saharan Africa (developing only) and Rent(as % of GDP) of Upper middle income?
Your answer should be very brief. 0.24. In the year 1985, what is the difference between the Rent(as % of GDP) of Sub-Saharan Africa (developing only) and Rent(as % of GDP) of Bulgaria?
Your answer should be compact. 0.67. In the year 1985, what is the difference between the Rent(as % of GDP) of Sub-Saharan Africa (developing only) and Rent(as % of GDP) of Korea (Republic)?
Provide a succinct answer. 0.66. In the year 1985, what is the difference between the Rent(as % of GDP) of Upper middle income and Rent(as % of GDP) of Bulgaria?
Ensure brevity in your answer.  0.44. In the year 1985, what is the difference between the Rent(as % of GDP) in Upper middle income and Rent(as % of GDP) in Korea (Republic)?
Your response must be concise. 0.42. In the year 1985, what is the difference between the Rent(as % of GDP) of Bulgaria and Rent(as % of GDP) of Korea (Republic)?
Your answer should be very brief. -0.01. In the year 2004, what is the difference between the Rent(as % of GDP) in Sub-Saharan Africa (developing only) and Rent(as % of GDP) in Upper middle income?
Keep it short and to the point. 0.04. In the year 2004, what is the difference between the Rent(as % of GDP) in Sub-Saharan Africa (developing only) and Rent(as % of GDP) in Bulgaria?
Give a very brief answer. 0.89. In the year 2004, what is the difference between the Rent(as % of GDP) of Sub-Saharan Africa (developing only) and Rent(as % of GDP) of Korea (Republic)?
Your answer should be compact. 0.89. In the year 2004, what is the difference between the Rent(as % of GDP) in Upper middle income and Rent(as % of GDP) in Bulgaria?
Offer a terse response. 0.85. In the year 2004, what is the difference between the Rent(as % of GDP) in Upper middle income and Rent(as % of GDP) in Korea (Republic)?
Your response must be concise. 0.84. In the year 2004, what is the difference between the Rent(as % of GDP) of Bulgaria and Rent(as % of GDP) of Korea (Republic)?
Offer a very short reply. -0.01. In the year 2005, what is the difference between the Rent(as % of GDP) of Sub-Saharan Africa (developing only) and Rent(as % of GDP) of Upper middle income?
Provide a short and direct response. 0.02. In the year 2005, what is the difference between the Rent(as % of GDP) of Sub-Saharan Africa (developing only) and Rent(as % of GDP) of Bulgaria?
Provide a succinct answer. 0.47. In the year 2005, what is the difference between the Rent(as % of GDP) of Sub-Saharan Africa (developing only) and Rent(as % of GDP) of Korea (Republic)?
Make the answer very short. 0.47. In the year 2005, what is the difference between the Rent(as % of GDP) of Upper middle income and Rent(as % of GDP) of Bulgaria?
Offer a terse response. 0.45. In the year 2005, what is the difference between the Rent(as % of GDP) of Upper middle income and Rent(as % of GDP) of Korea (Republic)?
Give a very brief answer. 0.45. In the year 2005, what is the difference between the Rent(as % of GDP) in Bulgaria and Rent(as % of GDP) in Korea (Republic)?
Provide a short and direct response. -0. In the year 2006, what is the difference between the Rent(as % of GDP) in Sub-Saharan Africa (developing only) and Rent(as % of GDP) in Upper middle income?
Make the answer very short. -0.02. In the year 2006, what is the difference between the Rent(as % of GDP) of Sub-Saharan Africa (developing only) and Rent(as % of GDP) of Bulgaria?
Ensure brevity in your answer.  0.46. In the year 2006, what is the difference between the Rent(as % of GDP) in Sub-Saharan Africa (developing only) and Rent(as % of GDP) in Korea (Republic)?
Give a very brief answer. 0.46. In the year 2006, what is the difference between the Rent(as % of GDP) in Upper middle income and Rent(as % of GDP) in Bulgaria?
Give a very brief answer. 0.48. In the year 2006, what is the difference between the Rent(as % of GDP) of Upper middle income and Rent(as % of GDP) of Korea (Republic)?
Give a very brief answer. 0.48. In the year 2006, what is the difference between the Rent(as % of GDP) in Bulgaria and Rent(as % of GDP) in Korea (Republic)?
Your response must be concise. -0. In the year 2007, what is the difference between the Rent(as % of GDP) of Sub-Saharan Africa (developing only) and Rent(as % of GDP) of Upper middle income?
Ensure brevity in your answer.  -0.04. In the year 2007, what is the difference between the Rent(as % of GDP) in Sub-Saharan Africa (developing only) and Rent(as % of GDP) in Bulgaria?
Offer a terse response. 0.69. In the year 2007, what is the difference between the Rent(as % of GDP) in Sub-Saharan Africa (developing only) and Rent(as % of GDP) in Korea (Republic)?
Ensure brevity in your answer.  0.68. In the year 2007, what is the difference between the Rent(as % of GDP) of Upper middle income and Rent(as % of GDP) of Bulgaria?
Your answer should be compact. 0.73. In the year 2007, what is the difference between the Rent(as % of GDP) of Upper middle income and Rent(as % of GDP) of Korea (Republic)?
Provide a succinct answer. 0.72. In the year 2007, what is the difference between the Rent(as % of GDP) in Bulgaria and Rent(as % of GDP) in Korea (Republic)?
Offer a very short reply. -0. In the year 2008, what is the difference between the Rent(as % of GDP) in Sub-Saharan Africa (developing only) and Rent(as % of GDP) in Upper middle income?
Keep it short and to the point. -0.14. In the year 2008, what is the difference between the Rent(as % of GDP) of Sub-Saharan Africa (developing only) and Rent(as % of GDP) of Bulgaria?
Your answer should be compact. 1.62. In the year 2008, what is the difference between the Rent(as % of GDP) in Sub-Saharan Africa (developing only) and Rent(as % of GDP) in Korea (Republic)?
Provide a succinct answer. 1.85. In the year 2008, what is the difference between the Rent(as % of GDP) of Upper middle income and Rent(as % of GDP) of Bulgaria?
Your answer should be very brief. 1.77. In the year 2008, what is the difference between the Rent(as % of GDP) in Upper middle income and Rent(as % of GDP) in Korea (Republic)?
Offer a terse response. 1.99. In the year 2008, what is the difference between the Rent(as % of GDP) in Bulgaria and Rent(as % of GDP) in Korea (Republic)?
Your answer should be compact. 0.22. In the year 2009, what is the difference between the Rent(as % of GDP) in Sub-Saharan Africa (developing only) and Rent(as % of GDP) in Upper middle income?
Your answer should be compact. -0.03. In the year 2009, what is the difference between the Rent(as % of GDP) of Sub-Saharan Africa (developing only) and Rent(as % of GDP) of Bulgaria?
Provide a succinct answer. 0.65. In the year 2009, what is the difference between the Rent(as % of GDP) of Sub-Saharan Africa (developing only) and Rent(as % of GDP) of Korea (Republic)?
Offer a very short reply. 0.64. In the year 2009, what is the difference between the Rent(as % of GDP) in Upper middle income and Rent(as % of GDP) in Bulgaria?
Provide a short and direct response. 0.68. In the year 2009, what is the difference between the Rent(as % of GDP) of Upper middle income and Rent(as % of GDP) of Korea (Republic)?
Keep it short and to the point. 0.67. In the year 2009, what is the difference between the Rent(as % of GDP) in Bulgaria and Rent(as % of GDP) in Korea (Republic)?
Offer a very short reply. -0. In the year 2010, what is the difference between the Rent(as % of GDP) of Sub-Saharan Africa (developing only) and Rent(as % of GDP) of Upper middle income?
Keep it short and to the point. -0.24. In the year 2010, what is the difference between the Rent(as % of GDP) of Sub-Saharan Africa (developing only) and Rent(as % of GDP) of Bulgaria?
Your answer should be very brief. 0.83. In the year 2010, what is the difference between the Rent(as % of GDP) in Sub-Saharan Africa (developing only) and Rent(as % of GDP) in Korea (Republic)?
Your answer should be compact. 0.89. In the year 2010, what is the difference between the Rent(as % of GDP) of Upper middle income and Rent(as % of GDP) of Bulgaria?
Offer a terse response. 1.07. In the year 2010, what is the difference between the Rent(as % of GDP) in Upper middle income and Rent(as % of GDP) in Korea (Republic)?
Make the answer very short. 1.13. In the year 2010, what is the difference between the Rent(as % of GDP) of Bulgaria and Rent(as % of GDP) of Korea (Republic)?
Give a very brief answer. 0.06. What is the ratio of the Rent(as % of GDP) in Sub-Saharan Africa (developing only) in 1985 to that in 2004?
Provide a succinct answer. 0.89. What is the ratio of the Rent(as % of GDP) of Upper middle income in 1985 to that in 2004?
Offer a terse response. 0.65. What is the ratio of the Rent(as % of GDP) of Bulgaria in 1985 to that in 2004?
Make the answer very short. 113.04. What is the ratio of the Rent(as % of GDP) in Korea (Republic) in 1985 to that in 2004?
Ensure brevity in your answer.  21.19. What is the ratio of the Rent(as % of GDP) in Sub-Saharan Africa (developing only) in 1985 to that in 2005?
Provide a short and direct response. 1.69. What is the ratio of the Rent(as % of GDP) in Upper middle income in 1985 to that in 2005?
Keep it short and to the point. 1.22. What is the ratio of the Rent(as % of GDP) in Bulgaria in 1985 to that in 2005?
Your answer should be very brief. 1823.69. What is the ratio of the Rent(as % of GDP) in Korea (Republic) in 1985 to that in 2005?
Your response must be concise. 48.45. What is the ratio of the Rent(as % of GDP) in Sub-Saharan Africa (developing only) in 1985 to that in 2006?
Ensure brevity in your answer.  1.72. What is the ratio of the Rent(as % of GDP) of Upper middle income in 1985 to that in 2006?
Your answer should be very brief. 1.15. What is the ratio of the Rent(as % of GDP) in Bulgaria in 1985 to that in 2006?
Your response must be concise. 419.83. What is the ratio of the Rent(as % of GDP) of Korea (Republic) in 1985 to that in 2006?
Give a very brief answer. 47. What is the ratio of the Rent(as % of GDP) of Sub-Saharan Africa (developing only) in 1985 to that in 2007?
Offer a terse response. 1.15. What is the ratio of the Rent(as % of GDP) in Upper middle income in 1985 to that in 2007?
Offer a very short reply. 0.76. What is the ratio of the Rent(as % of GDP) in Bulgaria in 1985 to that in 2007?
Your answer should be very brief. 166.02. What is the ratio of the Rent(as % of GDP) in Korea (Republic) in 1985 to that in 2007?
Provide a short and direct response. 27.66. What is the ratio of the Rent(as % of GDP) in Sub-Saharan Africa (developing only) in 1985 to that in 2008?
Give a very brief answer. 0.43. What is the ratio of the Rent(as % of GDP) in Upper middle income in 1985 to that in 2008?
Give a very brief answer. 0.28. What is the ratio of the Rent(as % of GDP) of Bulgaria in 1985 to that in 2008?
Make the answer very short. 0.5. What is the ratio of the Rent(as % of GDP) of Korea (Republic) in 1985 to that in 2008?
Keep it short and to the point. 7.97. What is the ratio of the Rent(as % of GDP) of Sub-Saharan Africa (developing only) in 1985 to that in 2009?
Your answer should be very brief. 1.22. What is the ratio of the Rent(as % of GDP) of Upper middle income in 1985 to that in 2009?
Your answer should be very brief. 0.82. What is the ratio of the Rent(as % of GDP) of Bulgaria in 1985 to that in 2009?
Provide a short and direct response. 146.61. What is the ratio of the Rent(as % of GDP) of Korea (Republic) in 1985 to that in 2009?
Your answer should be very brief. 24.58. What is the ratio of the Rent(as % of GDP) of Sub-Saharan Africa (developing only) in 1985 to that in 2010?
Your response must be concise. 0.88. What is the ratio of the Rent(as % of GDP) of Upper middle income in 1985 to that in 2010?
Ensure brevity in your answer.  0.49. What is the ratio of the Rent(as % of GDP) of Bulgaria in 1985 to that in 2010?
Offer a terse response. 1.8. What is the ratio of the Rent(as % of GDP) of Korea (Republic) in 1985 to that in 2010?
Your answer should be compact. 19.27. What is the ratio of the Rent(as % of GDP) of Sub-Saharan Africa (developing only) in 2004 to that in 2005?
Your answer should be very brief. 1.9. What is the ratio of the Rent(as % of GDP) of Upper middle income in 2004 to that in 2005?
Give a very brief answer. 1.88. What is the ratio of the Rent(as % of GDP) in Bulgaria in 2004 to that in 2005?
Ensure brevity in your answer.  16.13. What is the ratio of the Rent(as % of GDP) of Korea (Republic) in 2004 to that in 2005?
Ensure brevity in your answer.  2.29. What is the ratio of the Rent(as % of GDP) of Sub-Saharan Africa (developing only) in 2004 to that in 2006?
Give a very brief answer. 1.94. What is the ratio of the Rent(as % of GDP) of Upper middle income in 2004 to that in 2006?
Keep it short and to the point. 1.77. What is the ratio of the Rent(as % of GDP) in Bulgaria in 2004 to that in 2006?
Provide a succinct answer. 3.71. What is the ratio of the Rent(as % of GDP) of Korea (Republic) in 2004 to that in 2006?
Keep it short and to the point. 2.22. What is the ratio of the Rent(as % of GDP) in Sub-Saharan Africa (developing only) in 2004 to that in 2007?
Your response must be concise. 1.3. What is the ratio of the Rent(as % of GDP) of Upper middle income in 2004 to that in 2007?
Offer a very short reply. 1.17. What is the ratio of the Rent(as % of GDP) in Bulgaria in 2004 to that in 2007?
Give a very brief answer. 1.47. What is the ratio of the Rent(as % of GDP) of Korea (Republic) in 2004 to that in 2007?
Your response must be concise. 1.31. What is the ratio of the Rent(as % of GDP) in Sub-Saharan Africa (developing only) in 2004 to that in 2008?
Your response must be concise. 0.48. What is the ratio of the Rent(as % of GDP) of Upper middle income in 2004 to that in 2008?
Your answer should be compact. 0.42. What is the ratio of the Rent(as % of GDP) of Bulgaria in 2004 to that in 2008?
Your response must be concise. 0. What is the ratio of the Rent(as % of GDP) in Korea (Republic) in 2004 to that in 2008?
Your response must be concise. 0.38. What is the ratio of the Rent(as % of GDP) in Sub-Saharan Africa (developing only) in 2004 to that in 2009?
Offer a very short reply. 1.38. What is the ratio of the Rent(as % of GDP) of Upper middle income in 2004 to that in 2009?
Provide a short and direct response. 1.25. What is the ratio of the Rent(as % of GDP) of Bulgaria in 2004 to that in 2009?
Ensure brevity in your answer.  1.3. What is the ratio of the Rent(as % of GDP) in Korea (Republic) in 2004 to that in 2009?
Provide a short and direct response. 1.16. What is the ratio of the Rent(as % of GDP) in Sub-Saharan Africa (developing only) in 2004 to that in 2010?
Provide a succinct answer. 1. What is the ratio of the Rent(as % of GDP) of Upper middle income in 2004 to that in 2010?
Provide a succinct answer. 0.75. What is the ratio of the Rent(as % of GDP) of Bulgaria in 2004 to that in 2010?
Provide a succinct answer. 0.02. What is the ratio of the Rent(as % of GDP) in Korea (Republic) in 2004 to that in 2010?
Provide a short and direct response. 0.91. What is the ratio of the Rent(as % of GDP) in Sub-Saharan Africa (developing only) in 2005 to that in 2006?
Keep it short and to the point. 1.02. What is the ratio of the Rent(as % of GDP) in Upper middle income in 2005 to that in 2006?
Give a very brief answer. 0.94. What is the ratio of the Rent(as % of GDP) in Bulgaria in 2005 to that in 2006?
Your response must be concise. 0.23. What is the ratio of the Rent(as % of GDP) in Korea (Republic) in 2005 to that in 2006?
Provide a succinct answer. 0.97. What is the ratio of the Rent(as % of GDP) of Sub-Saharan Africa (developing only) in 2005 to that in 2007?
Offer a terse response. 0.68. What is the ratio of the Rent(as % of GDP) of Upper middle income in 2005 to that in 2007?
Your answer should be very brief. 0.62. What is the ratio of the Rent(as % of GDP) in Bulgaria in 2005 to that in 2007?
Give a very brief answer. 0.09. What is the ratio of the Rent(as % of GDP) of Korea (Republic) in 2005 to that in 2007?
Your answer should be very brief. 0.57. What is the ratio of the Rent(as % of GDP) in Sub-Saharan Africa (developing only) in 2005 to that in 2008?
Keep it short and to the point. 0.25. What is the ratio of the Rent(as % of GDP) of Upper middle income in 2005 to that in 2008?
Your answer should be very brief. 0.23. What is the ratio of the Rent(as % of GDP) in Korea (Republic) in 2005 to that in 2008?
Give a very brief answer. 0.16. What is the ratio of the Rent(as % of GDP) in Sub-Saharan Africa (developing only) in 2005 to that in 2009?
Keep it short and to the point. 0.72. What is the ratio of the Rent(as % of GDP) of Upper middle income in 2005 to that in 2009?
Ensure brevity in your answer.  0.67. What is the ratio of the Rent(as % of GDP) of Bulgaria in 2005 to that in 2009?
Offer a terse response. 0.08. What is the ratio of the Rent(as % of GDP) of Korea (Republic) in 2005 to that in 2009?
Your response must be concise. 0.51. What is the ratio of the Rent(as % of GDP) of Sub-Saharan Africa (developing only) in 2005 to that in 2010?
Offer a very short reply. 0.52. What is the ratio of the Rent(as % of GDP) in Upper middle income in 2005 to that in 2010?
Give a very brief answer. 0.4. What is the ratio of the Rent(as % of GDP) in Korea (Republic) in 2005 to that in 2010?
Your answer should be compact. 0.4. What is the ratio of the Rent(as % of GDP) of Sub-Saharan Africa (developing only) in 2006 to that in 2007?
Provide a succinct answer. 0.67. What is the ratio of the Rent(as % of GDP) in Upper middle income in 2006 to that in 2007?
Give a very brief answer. 0.66. What is the ratio of the Rent(as % of GDP) of Bulgaria in 2006 to that in 2007?
Your response must be concise. 0.4. What is the ratio of the Rent(as % of GDP) of Korea (Republic) in 2006 to that in 2007?
Give a very brief answer. 0.59. What is the ratio of the Rent(as % of GDP) of Sub-Saharan Africa (developing only) in 2006 to that in 2008?
Your answer should be compact. 0.25. What is the ratio of the Rent(as % of GDP) in Upper middle income in 2006 to that in 2008?
Make the answer very short. 0.24. What is the ratio of the Rent(as % of GDP) in Bulgaria in 2006 to that in 2008?
Offer a terse response. 0. What is the ratio of the Rent(as % of GDP) in Korea (Republic) in 2006 to that in 2008?
Offer a very short reply. 0.17. What is the ratio of the Rent(as % of GDP) in Sub-Saharan Africa (developing only) in 2006 to that in 2009?
Ensure brevity in your answer.  0.71. What is the ratio of the Rent(as % of GDP) in Upper middle income in 2006 to that in 2009?
Your response must be concise. 0.71. What is the ratio of the Rent(as % of GDP) in Bulgaria in 2006 to that in 2009?
Your answer should be very brief. 0.35. What is the ratio of the Rent(as % of GDP) in Korea (Republic) in 2006 to that in 2009?
Give a very brief answer. 0.52. What is the ratio of the Rent(as % of GDP) of Sub-Saharan Africa (developing only) in 2006 to that in 2010?
Make the answer very short. 0.51. What is the ratio of the Rent(as % of GDP) of Upper middle income in 2006 to that in 2010?
Provide a succinct answer. 0.42. What is the ratio of the Rent(as % of GDP) of Bulgaria in 2006 to that in 2010?
Your answer should be very brief. 0. What is the ratio of the Rent(as % of GDP) of Korea (Republic) in 2006 to that in 2010?
Offer a very short reply. 0.41. What is the ratio of the Rent(as % of GDP) of Sub-Saharan Africa (developing only) in 2007 to that in 2008?
Offer a terse response. 0.37. What is the ratio of the Rent(as % of GDP) of Upper middle income in 2007 to that in 2008?
Offer a very short reply. 0.36. What is the ratio of the Rent(as % of GDP) in Bulgaria in 2007 to that in 2008?
Keep it short and to the point. 0. What is the ratio of the Rent(as % of GDP) of Korea (Republic) in 2007 to that in 2008?
Provide a short and direct response. 0.29. What is the ratio of the Rent(as % of GDP) of Sub-Saharan Africa (developing only) in 2007 to that in 2009?
Offer a very short reply. 1.06. What is the ratio of the Rent(as % of GDP) in Upper middle income in 2007 to that in 2009?
Give a very brief answer. 1.07. What is the ratio of the Rent(as % of GDP) of Bulgaria in 2007 to that in 2009?
Make the answer very short. 0.88. What is the ratio of the Rent(as % of GDP) of Korea (Republic) in 2007 to that in 2009?
Provide a short and direct response. 0.89. What is the ratio of the Rent(as % of GDP) of Sub-Saharan Africa (developing only) in 2007 to that in 2010?
Offer a terse response. 0.77. What is the ratio of the Rent(as % of GDP) of Upper middle income in 2007 to that in 2010?
Ensure brevity in your answer.  0.64. What is the ratio of the Rent(as % of GDP) in Bulgaria in 2007 to that in 2010?
Your answer should be very brief. 0.01. What is the ratio of the Rent(as % of GDP) of Korea (Republic) in 2007 to that in 2010?
Ensure brevity in your answer.  0.7. What is the ratio of the Rent(as % of GDP) in Sub-Saharan Africa (developing only) in 2008 to that in 2009?
Keep it short and to the point. 2.87. What is the ratio of the Rent(as % of GDP) of Upper middle income in 2008 to that in 2009?
Provide a succinct answer. 2.96. What is the ratio of the Rent(as % of GDP) in Bulgaria in 2008 to that in 2009?
Your answer should be very brief. 295.92. What is the ratio of the Rent(as % of GDP) in Korea (Republic) in 2008 to that in 2009?
Offer a very short reply. 3.08. What is the ratio of the Rent(as % of GDP) of Sub-Saharan Africa (developing only) in 2008 to that in 2010?
Your response must be concise. 2.08. What is the ratio of the Rent(as % of GDP) of Upper middle income in 2008 to that in 2010?
Your answer should be very brief. 1.77. What is the ratio of the Rent(as % of GDP) of Bulgaria in 2008 to that in 2010?
Give a very brief answer. 3.64. What is the ratio of the Rent(as % of GDP) of Korea (Republic) in 2008 to that in 2010?
Offer a very short reply. 2.42. What is the ratio of the Rent(as % of GDP) of Sub-Saharan Africa (developing only) in 2009 to that in 2010?
Provide a short and direct response. 0.72. What is the ratio of the Rent(as % of GDP) in Upper middle income in 2009 to that in 2010?
Your answer should be compact. 0.6. What is the ratio of the Rent(as % of GDP) of Bulgaria in 2009 to that in 2010?
Provide a succinct answer. 0.01. What is the ratio of the Rent(as % of GDP) of Korea (Republic) in 2009 to that in 2010?
Make the answer very short. 0.78. What is the difference between the highest and the second highest Rent(as % of GDP) of Sub-Saharan Africa (developing only)?
Make the answer very short. 0.97. What is the difference between the highest and the second highest Rent(as % of GDP) of Upper middle income?
Provide a succinct answer. 0.87. What is the difference between the highest and the second highest Rent(as % of GDP) in Bulgaria?
Make the answer very short. 0.12. What is the difference between the highest and the second highest Rent(as % of GDP) of Korea (Republic)?
Offer a terse response. 0.12. What is the difference between the highest and the lowest Rent(as % of GDP) in Sub-Saharan Africa (developing only)?
Your response must be concise. 1.4. What is the difference between the highest and the lowest Rent(as % of GDP) in Upper middle income?
Provide a succinct answer. 1.55. What is the difference between the highest and the lowest Rent(as % of GDP) of Bulgaria?
Provide a short and direct response. 0.24. What is the difference between the highest and the lowest Rent(as % of GDP) of Korea (Republic)?
Your answer should be very brief. 0.13. 